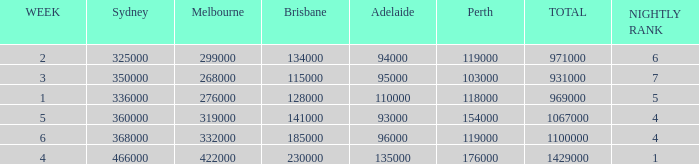What was the total rating on week 3?  931000.0. 